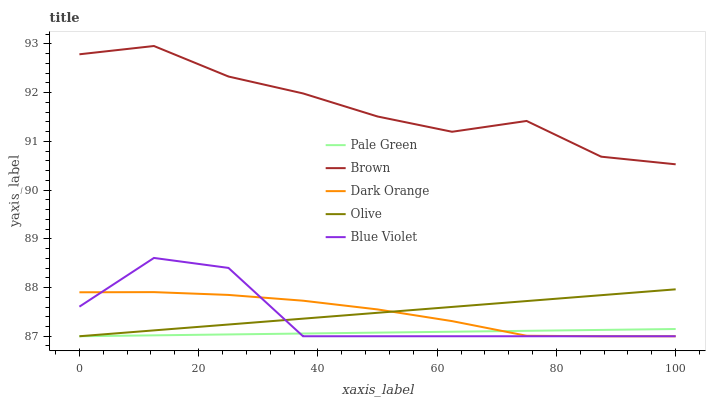Does Pale Green have the minimum area under the curve?
Answer yes or no. Yes. Does Brown have the maximum area under the curve?
Answer yes or no. Yes. Does Brown have the minimum area under the curve?
Answer yes or no. No. Does Pale Green have the maximum area under the curve?
Answer yes or no. No. Is Olive the smoothest?
Answer yes or no. Yes. Is Blue Violet the roughest?
Answer yes or no. Yes. Is Brown the smoothest?
Answer yes or no. No. Is Brown the roughest?
Answer yes or no. No. Does Olive have the lowest value?
Answer yes or no. Yes. Does Brown have the lowest value?
Answer yes or no. No. Does Brown have the highest value?
Answer yes or no. Yes. Does Pale Green have the highest value?
Answer yes or no. No. Is Olive less than Brown?
Answer yes or no. Yes. Is Brown greater than Dark Orange?
Answer yes or no. Yes. Does Olive intersect Blue Violet?
Answer yes or no. Yes. Is Olive less than Blue Violet?
Answer yes or no. No. Is Olive greater than Blue Violet?
Answer yes or no. No. Does Olive intersect Brown?
Answer yes or no. No. 